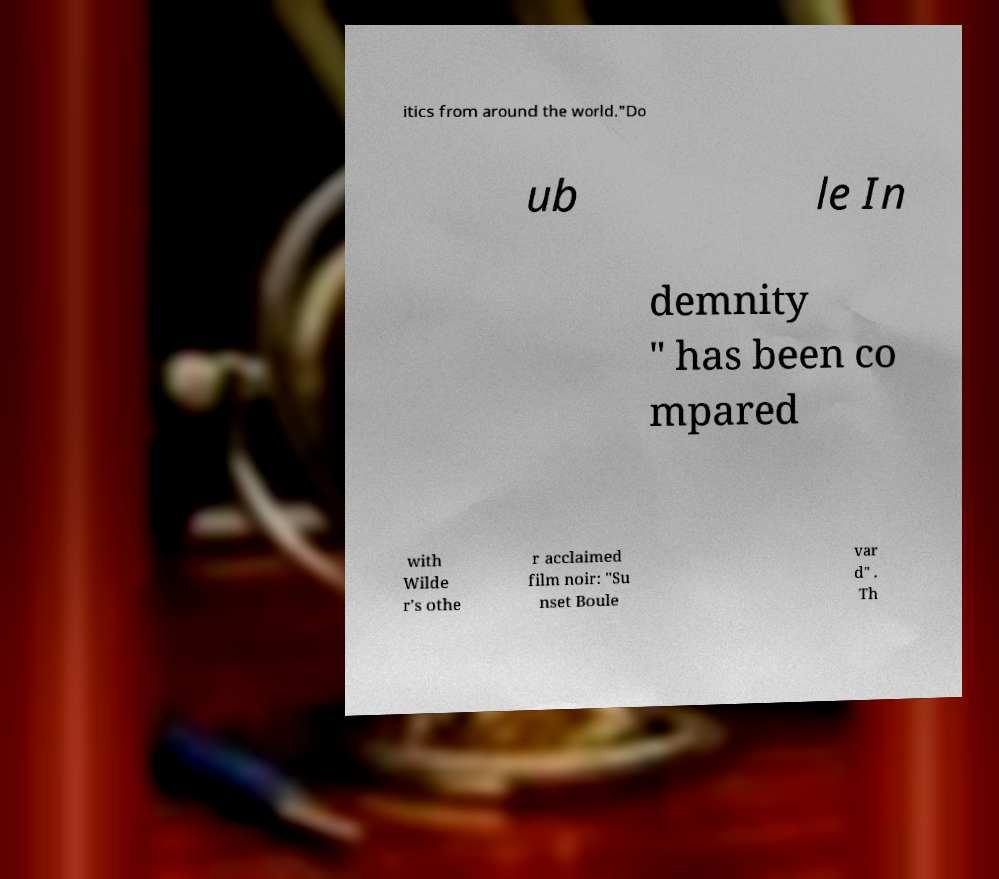I need the written content from this picture converted into text. Can you do that? itics from around the world."Do ub le In demnity " has been co mpared with Wilde r's othe r acclaimed film noir: "Su nset Boule var d" . Th 